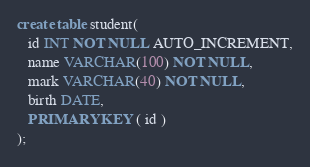Convert code to text. <code><loc_0><loc_0><loc_500><loc_500><_SQL_>create table student(
   id INT NOT NULL AUTO_INCREMENT,
   name VARCHAR(100) NOT NULL,
   mark VARCHAR(40) NOT NULL,
   birth DATE,
   PRIMARY KEY ( id )
);</code> 